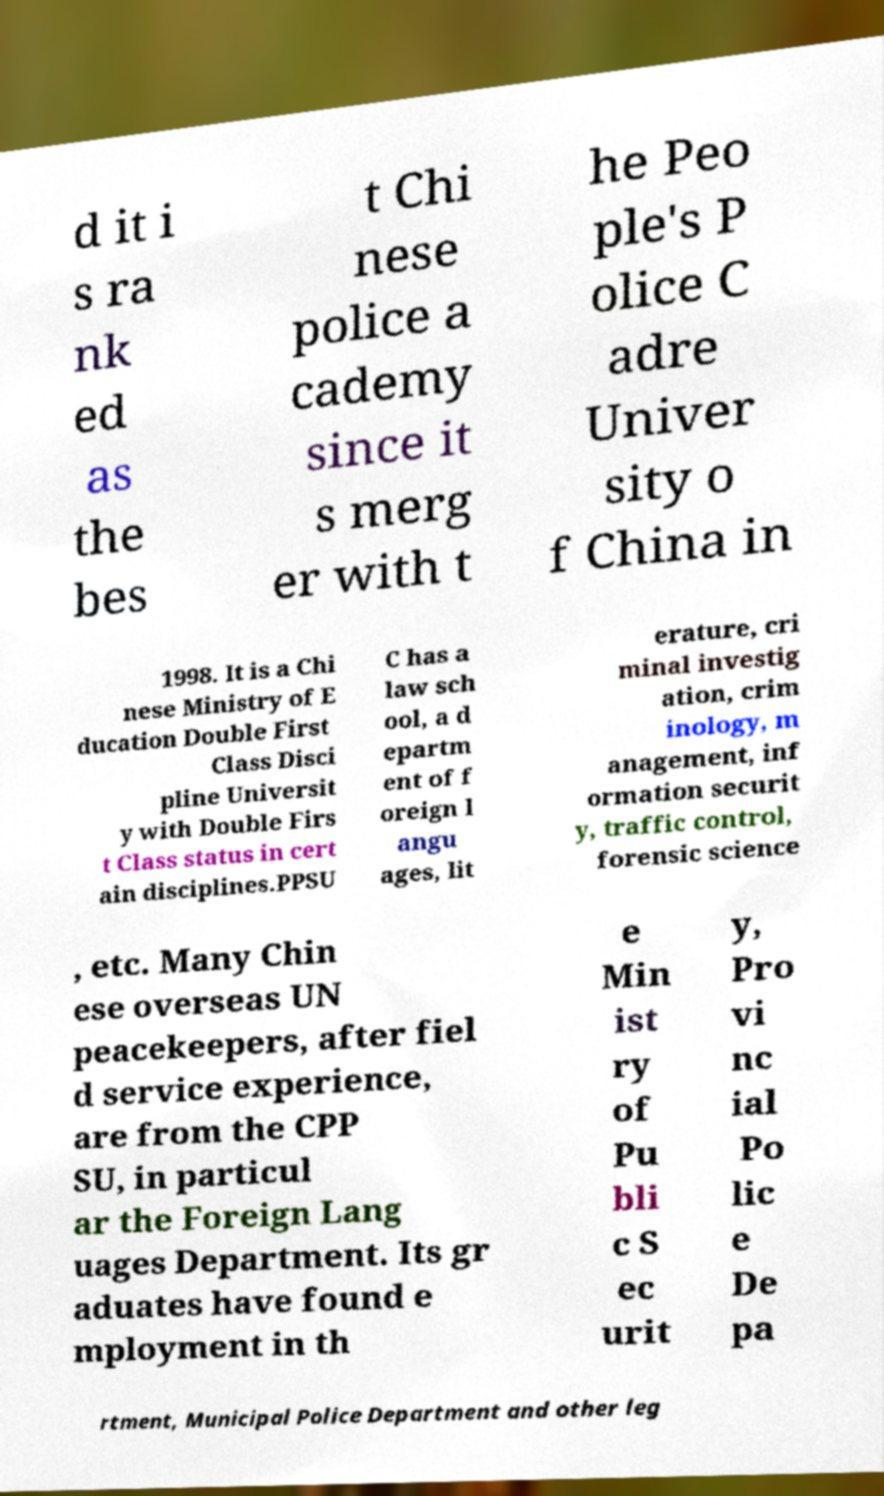For documentation purposes, I need the text within this image transcribed. Could you provide that? d it i s ra nk ed as the bes t Chi nese police a cademy since it s merg er with t he Peo ple's P olice C adre Univer sity o f China in 1998. It is a Chi nese Ministry of E ducation Double First Class Disci pline Universit y with Double Firs t Class status in cert ain disciplines.PPSU C has a law sch ool, a d epartm ent of f oreign l angu ages, lit erature, cri minal investig ation, crim inology, m anagement, inf ormation securit y, traffic control, forensic science , etc. Many Chin ese overseas UN peacekeepers, after fiel d service experience, are from the CPP SU, in particul ar the Foreign Lang uages Department. Its gr aduates have found e mployment in th e Min ist ry of Pu bli c S ec urit y, Pro vi nc ial Po lic e De pa rtment, Municipal Police Department and other leg 